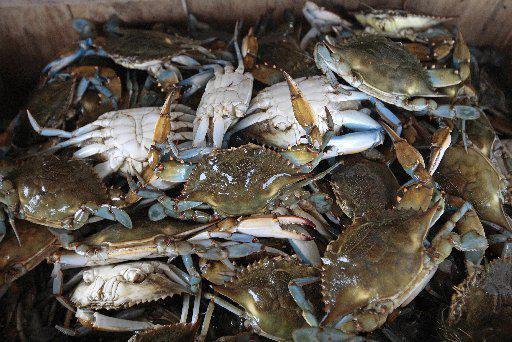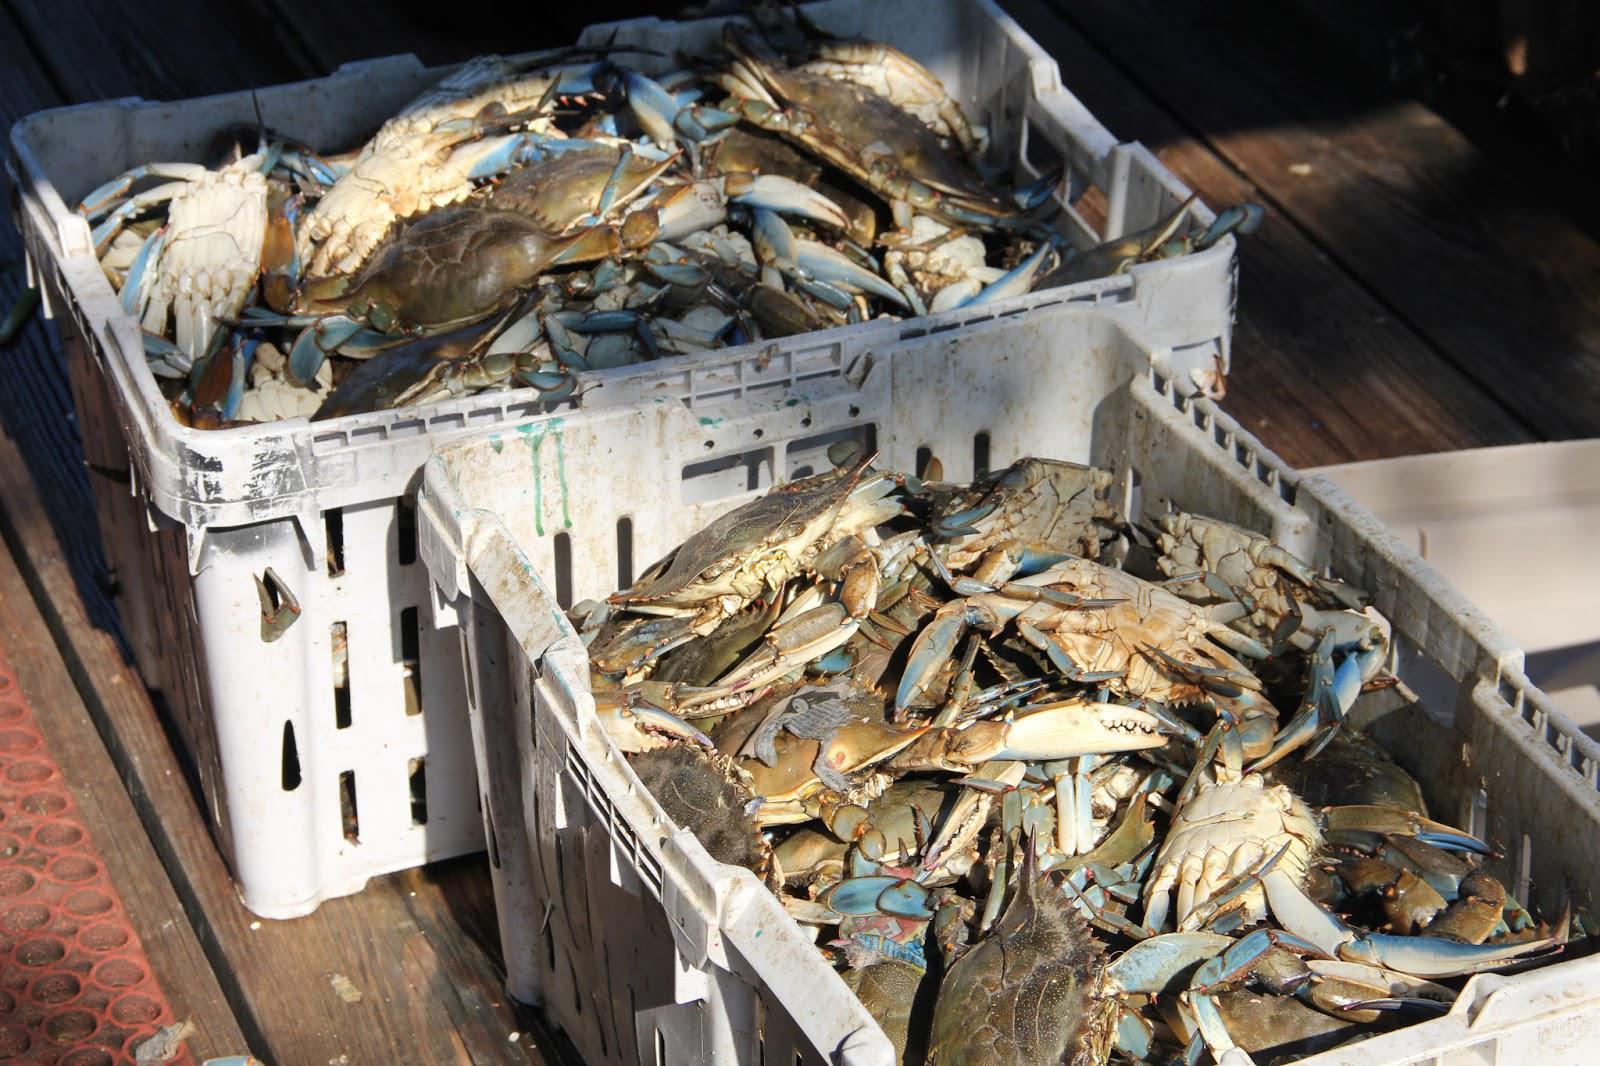The first image is the image on the left, the second image is the image on the right. Evaluate the accuracy of this statement regarding the images: "In at least one image, the crabs have a blue tint near the claws.". Is it true? Answer yes or no. Yes. The first image is the image on the left, the second image is the image on the right. Considering the images on both sides, is "Crabs are being dumped out of a container." valid? Answer yes or no. No. 